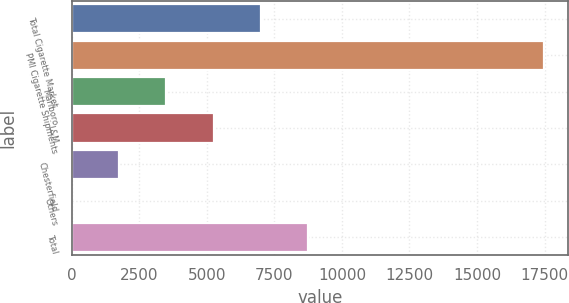Convert chart to OTSL. <chart><loc_0><loc_0><loc_500><loc_500><bar_chart><fcel>Total Cigarette Market<fcel>PMI Cigarette Shipments<fcel>Marlboro<fcel>L&M<fcel>Chesterfield<fcel>Others<fcel>Total<nl><fcel>6995.86<fcel>17485<fcel>3499.48<fcel>5247.67<fcel>1751.29<fcel>3.1<fcel>8744.05<nl></chart> 